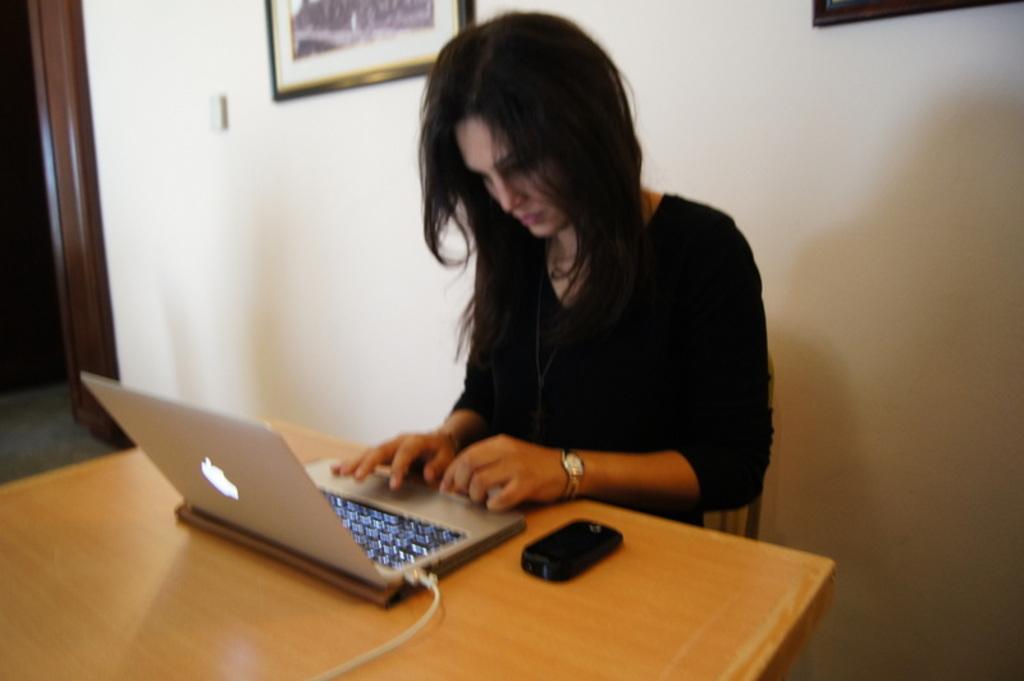Could you give a brief overview of what you see in this image? As we can see in the image there is a white color wall, photo frame, a woman sitting on chair and there is a table. On table there is a laptop and mobile phone. 